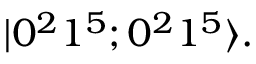Convert formula to latex. <formula><loc_0><loc_0><loc_500><loc_500>| 0 ^ { 2 } 1 ^ { 5 } ; 0 ^ { 2 } 1 ^ { 5 } \rangle .</formula> 